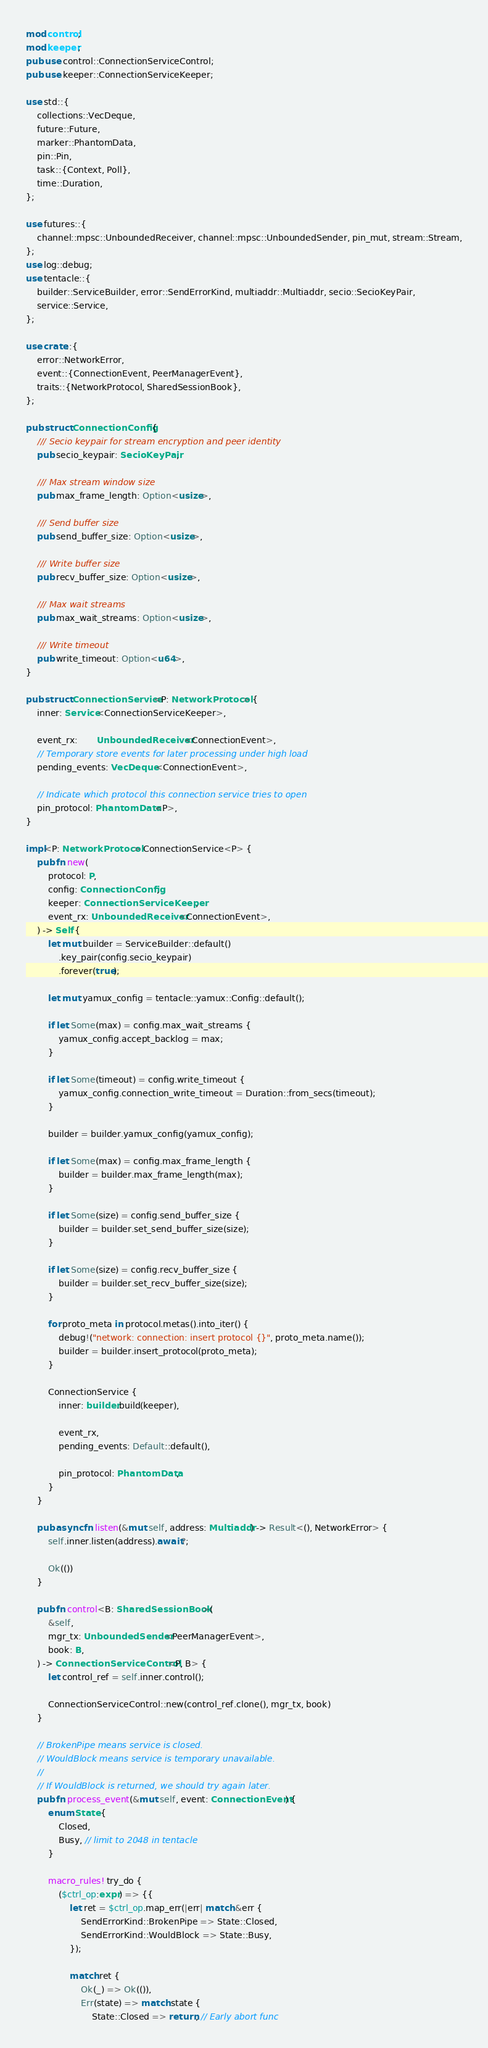<code> <loc_0><loc_0><loc_500><loc_500><_Rust_>mod control;
mod keeper;
pub use control::ConnectionServiceControl;
pub use keeper::ConnectionServiceKeeper;

use std::{
    collections::VecDeque,
    future::Future,
    marker::PhantomData,
    pin::Pin,
    task::{Context, Poll},
    time::Duration,
};

use futures::{
    channel::mpsc::UnboundedReceiver, channel::mpsc::UnboundedSender, pin_mut, stream::Stream,
};
use log::debug;
use tentacle::{
    builder::ServiceBuilder, error::SendErrorKind, multiaddr::Multiaddr, secio::SecioKeyPair,
    service::Service,
};

use crate::{
    error::NetworkError,
    event::{ConnectionEvent, PeerManagerEvent},
    traits::{NetworkProtocol, SharedSessionBook},
};

pub struct ConnectionConfig {
    /// Secio keypair for stream encryption and peer identity
    pub secio_keypair: SecioKeyPair,

    /// Max stream window size
    pub max_frame_length: Option<usize>,

    /// Send buffer size
    pub send_buffer_size: Option<usize>,

    /// Write buffer size
    pub recv_buffer_size: Option<usize>,

    /// Max wait streams
    pub max_wait_streams: Option<usize>,

    /// Write timeout
    pub write_timeout: Option<u64>,
}

pub struct ConnectionService<P: NetworkProtocol> {
    inner: Service<ConnectionServiceKeeper>,

    event_rx:       UnboundedReceiver<ConnectionEvent>,
    // Temporary store events for later processing under high load
    pending_events: VecDeque<ConnectionEvent>,

    // Indicate which protocol this connection service tries to open
    pin_protocol: PhantomData<P>,
}

impl<P: NetworkProtocol> ConnectionService<P> {
    pub fn new(
        protocol: P,
        config: ConnectionConfig,
        keeper: ConnectionServiceKeeper,
        event_rx: UnboundedReceiver<ConnectionEvent>,
    ) -> Self {
        let mut builder = ServiceBuilder::default()
            .key_pair(config.secio_keypair)
            .forever(true);

        let mut yamux_config = tentacle::yamux::Config::default();

        if let Some(max) = config.max_wait_streams {
            yamux_config.accept_backlog = max;
        }

        if let Some(timeout) = config.write_timeout {
            yamux_config.connection_write_timeout = Duration::from_secs(timeout);
        }

        builder = builder.yamux_config(yamux_config);

        if let Some(max) = config.max_frame_length {
            builder = builder.max_frame_length(max);
        }

        if let Some(size) = config.send_buffer_size {
            builder = builder.set_send_buffer_size(size);
        }

        if let Some(size) = config.recv_buffer_size {
            builder = builder.set_recv_buffer_size(size);
        }

        for proto_meta in protocol.metas().into_iter() {
            debug!("network: connection: insert protocol {}", proto_meta.name());
            builder = builder.insert_protocol(proto_meta);
        }

        ConnectionService {
            inner: builder.build(keeper),

            event_rx,
            pending_events: Default::default(),

            pin_protocol: PhantomData,
        }
    }

    pub async fn listen(&mut self, address: Multiaddr) -> Result<(), NetworkError> {
        self.inner.listen(address).await?;

        Ok(())
    }

    pub fn control<B: SharedSessionBook>(
        &self,
        mgr_tx: UnboundedSender<PeerManagerEvent>,
        book: B,
    ) -> ConnectionServiceControl<P, B> {
        let control_ref = self.inner.control();

        ConnectionServiceControl::new(control_ref.clone(), mgr_tx, book)
    }

    // BrokenPipe means service is closed.
    // WouldBlock means service is temporary unavailable.
    //
    // If WouldBlock is returned, we should try again later.
    pub fn process_event(&mut self, event: ConnectionEvent) {
        enum State {
            Closed,
            Busy, // limit to 2048 in tentacle
        }

        macro_rules! try_do {
            ($ctrl_op:expr) => {{
                let ret = $ctrl_op.map_err(|err| match &err {
                    SendErrorKind::BrokenPipe => State::Closed,
                    SendErrorKind::WouldBlock => State::Busy,
                });

                match ret {
                    Ok(_) => Ok(()),
                    Err(state) => match state {
                        State::Closed => return, // Early abort func</code> 